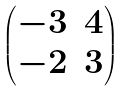<formula> <loc_0><loc_0><loc_500><loc_500>\begin{pmatrix} - 3 & 4 \\ - 2 & 3 \end{pmatrix}</formula> 